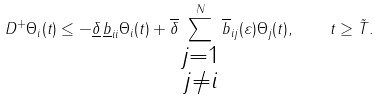<formula> <loc_0><loc_0><loc_500><loc_500>D ^ { + } \Theta _ { i } ( t ) \leq - \underline { \delta } \, \underline { b } _ { i i } \Theta _ { i } ( t ) + \overline { \delta } \sum _ { \substack { j = 1 \\ j \neq i } } ^ { N } \overline { b } _ { i j } ( \varepsilon ) \Theta _ { j } ( t ) , \quad t \geq \tilde { T } .</formula> 